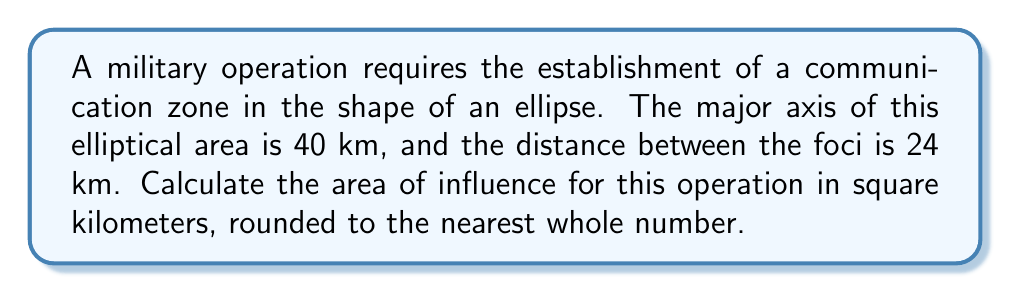Show me your answer to this math problem. To solve this problem, we'll follow these steps:

1) First, recall the formula for the area of an ellipse:
   $$A = \pi ab$$
   where $a$ is the length of the semi-major axis and $b$ is the length of the semi-minor axis.

2) We're given that the major axis is 40 km, so $a = 20$ km.

3) We need to find $b$. We can use the relationship between the semi-major axis $a$, the semi-minor axis $b$, and the distance between the foci $c$:
   $$a^2 = b^2 + c^2$$

4) We're told that the distance between the foci is 24 km, so $c = 12$ km.

5) Let's substitute our known values into the equation:
   $$20^2 = b^2 + 12^2$$

6) Simplify:
   $$400 = b^2 + 144$$

7) Solve for $b$:
   $$b^2 = 400 - 144 = 256$$
   $$b = \sqrt{256} = 16$$

8) Now we have both $a$ and $b$. Let's calculate the area:
   $$A = \pi ab = \pi(20)(16) = 320\pi$$

9) Calculate and round to the nearest whole number:
   $$A \approx 1005$$ km²
Answer: 1005 km² 